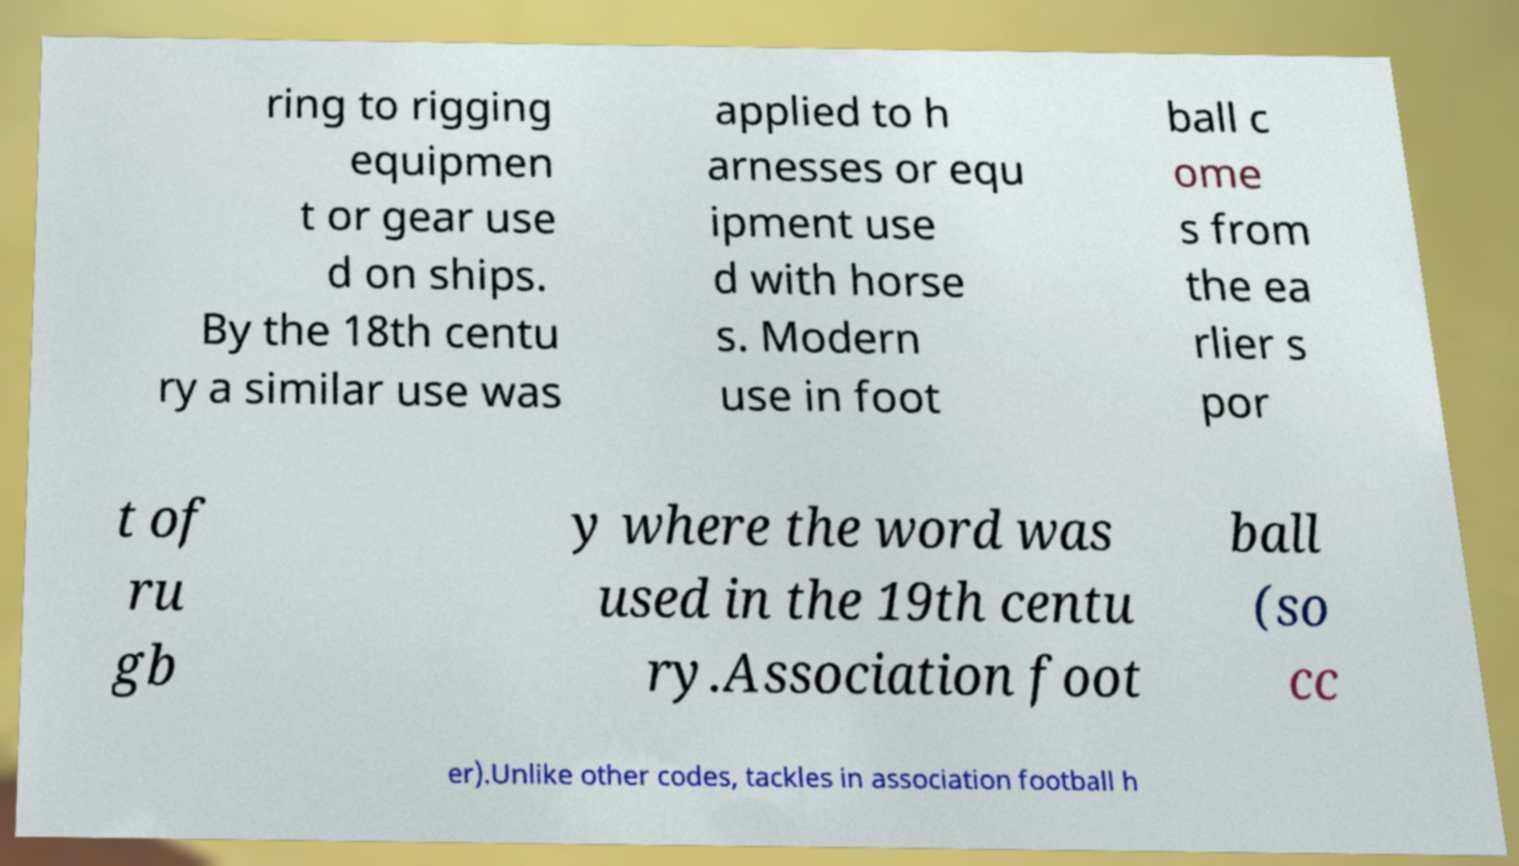For documentation purposes, I need the text within this image transcribed. Could you provide that? ring to rigging equipmen t or gear use d on ships. By the 18th centu ry a similar use was applied to h arnesses or equ ipment use d with horse s. Modern use in foot ball c ome s from the ea rlier s por t of ru gb y where the word was used in the 19th centu ry.Association foot ball (so cc er).Unlike other codes, tackles in association football h 